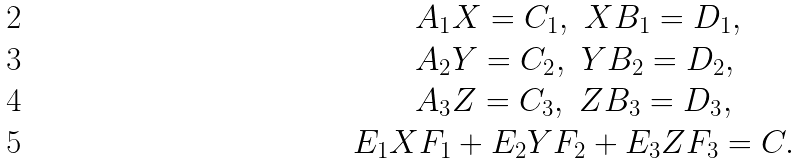Convert formula to latex. <formula><loc_0><loc_0><loc_500><loc_500>A _ { 1 } & X = C _ { 1 } , \ X B _ { 1 } = D _ { 1 } , \\ A _ { 2 } & Y = C _ { 2 } , \ Y B _ { 2 } = D _ { 2 } , \\ A _ { 3 } & Z = C _ { 3 } , \ Z B _ { 3 } = D _ { 3 } , \\ E _ { 1 } X F _ { 1 } & + E _ { 2 } Y F _ { 2 } + E _ { 3 } Z F _ { 3 } = C .</formula> 